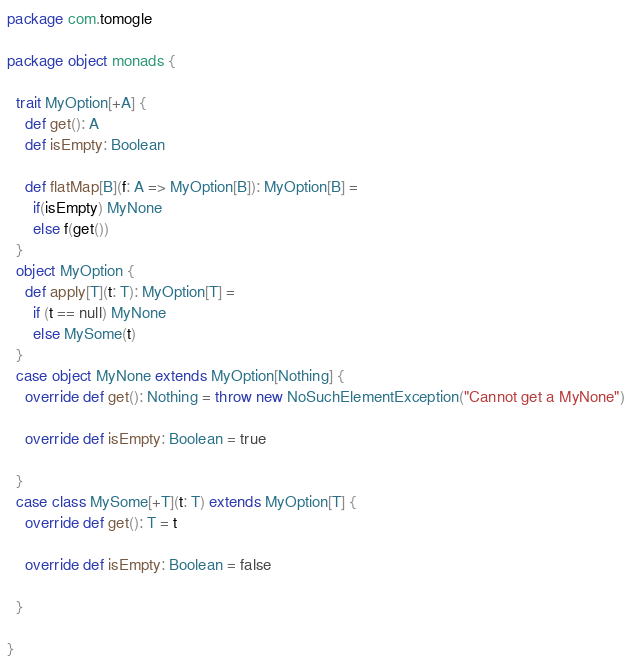Convert code to text. <code><loc_0><loc_0><loc_500><loc_500><_Scala_>package com.tomogle

package object monads {

  trait MyOption[+A] {
    def get(): A
    def isEmpty: Boolean

    def flatMap[B](f: A => MyOption[B]): MyOption[B] =
      if(isEmpty) MyNone
      else f(get())
  }
  object MyOption {
    def apply[T](t: T): MyOption[T] =
      if (t == null) MyNone
      else MySome(t)
  }
  case object MyNone extends MyOption[Nothing] {
    override def get(): Nothing = throw new NoSuchElementException("Cannot get a MyNone")

    override def isEmpty: Boolean = true

  }
  case class MySome[+T](t: T) extends MyOption[T] {
    override def get(): T = t

    override def isEmpty: Boolean = false

  }

}
</code> 